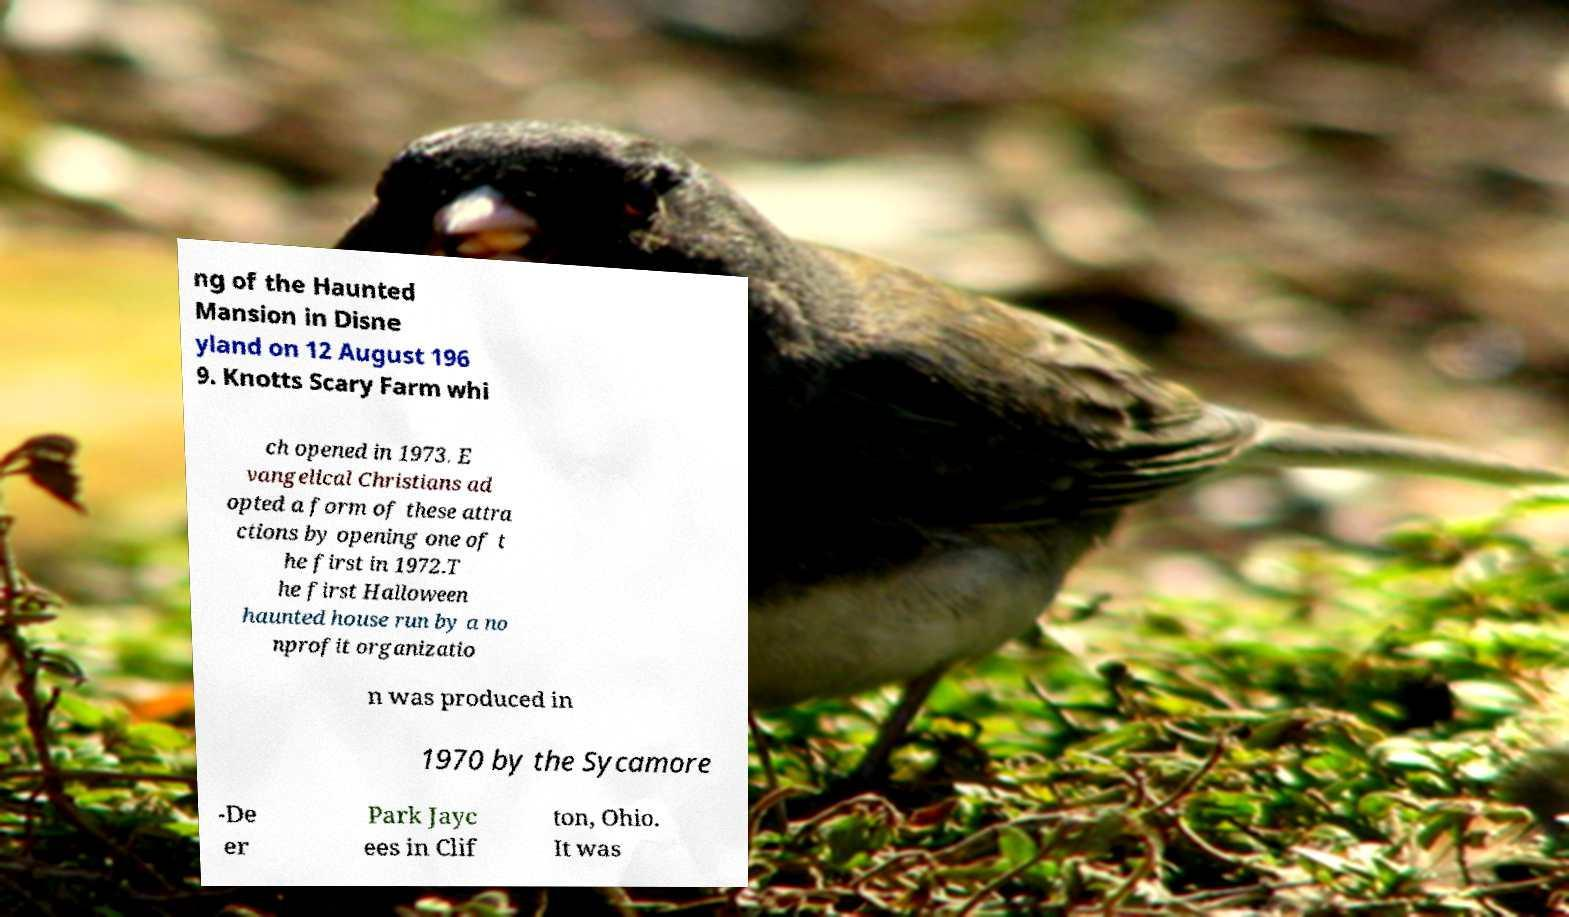I need the written content from this picture converted into text. Can you do that? ng of the Haunted Mansion in Disne yland on 12 August 196 9. Knotts Scary Farm whi ch opened in 1973. E vangelical Christians ad opted a form of these attra ctions by opening one of t he first in 1972.T he first Halloween haunted house run by a no nprofit organizatio n was produced in 1970 by the Sycamore -De er Park Jayc ees in Clif ton, Ohio. It was 